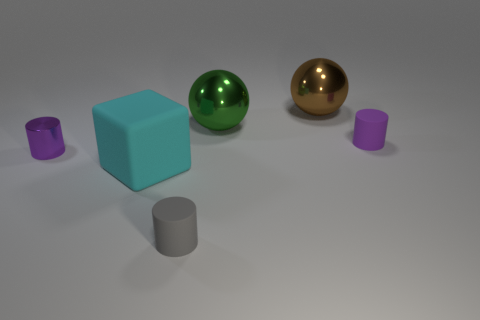There is a block left of the small cylinder that is right of the big brown metallic object; what is its material?
Offer a very short reply. Rubber. Is there another large shiny thing of the same shape as the brown thing?
Your answer should be very brief. Yes. What is the shape of the big cyan object?
Make the answer very short. Cube. What is the material of the purple cylinder that is on the left side of the small rubber object to the left of the rubber object that is on the right side of the green object?
Make the answer very short. Metal. Are there more metal things that are on the right side of the small gray rubber object than cyan things?
Offer a terse response. Yes. What is the material of the green object that is the same size as the brown metal sphere?
Give a very brief answer. Metal. Is there a purple matte cylinder that has the same size as the brown metal ball?
Provide a succinct answer. No. What is the size of the shiny ball that is on the right side of the green object?
Your response must be concise. Large. How big is the brown thing?
Your answer should be very brief. Large. What number of cylinders are either large blue rubber objects or big rubber things?
Keep it short and to the point. 0. 